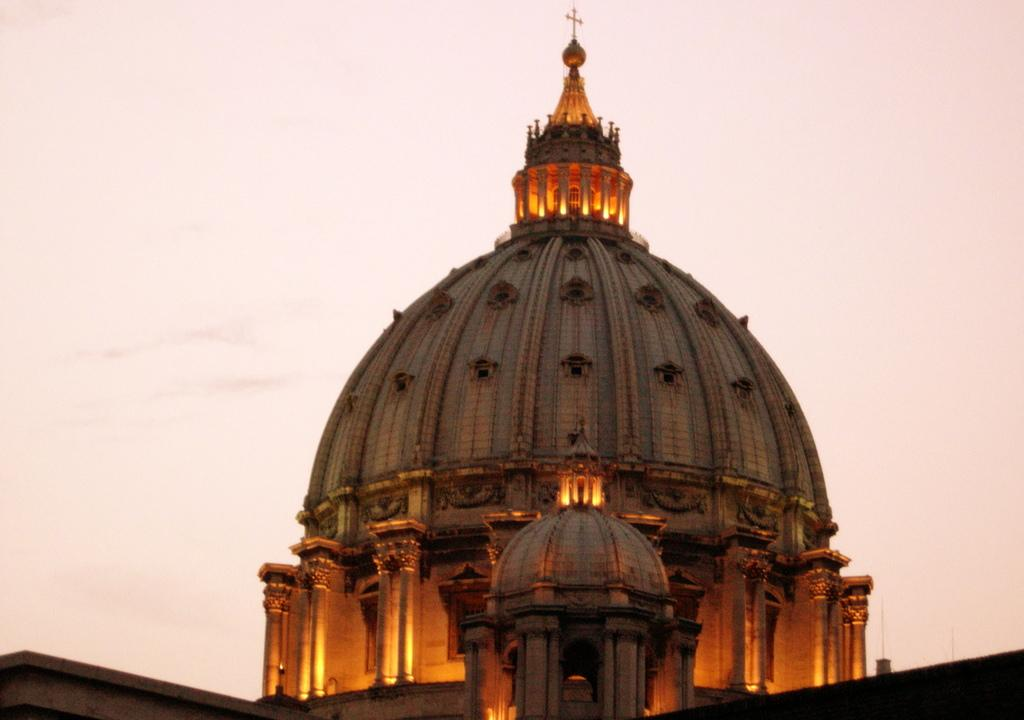What type of building is in the image? There is a church in the image. What is on top of the church? There is a cross symbol on top of the church. What can be seen in the image besides the church? There are lights visible in the image. What is visible in the background of the image? The sky is visible in the image. How many worms can be seen crawling on the church in the image? There are no worms present in the image; it features a church with a cross symbol on top. What is the size of the thumb visible in the image? There is no thumb present in the image. 